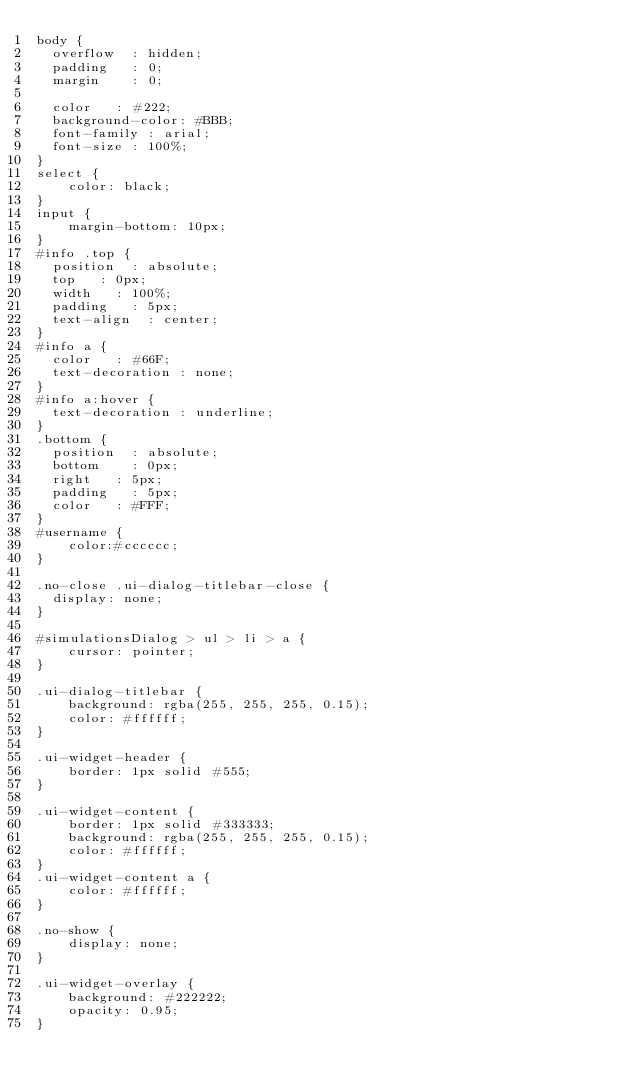Convert code to text. <code><loc_0><loc_0><loc_500><loc_500><_CSS_>body {
	overflow	: hidden;
	padding		: 0;
	margin		: 0;

	color		: #222;
	background-color: #BBB;
	font-family	: arial;
	font-size	: 100%;
}
select {
    color: black;
}
input {
    margin-bottom: 10px;
}
#info .top {
	position	: absolute;
	top		: 0px;
	width		: 100%;
	padding		: 5px;
	text-align	: center;
}
#info a {
	color		: #66F;
	text-decoration	: none;
}
#info a:hover {
	text-decoration	: underline;
}
.bottom {
	position	: absolute;
	bottom		: 0px;
	right		: 5px;
	padding		: 5px;
	color		: #FFF;
}
#username {
    color:#cccccc;
}

.no-close .ui-dialog-titlebar-close {
	display: none;
}

#simulationsDialog > ul > li > a {
    cursor: pointer;
}

.ui-dialog-titlebar {
    background: rgba(255, 255, 255, 0.15);
    color: #ffffff;
}

.ui-widget-header {
    border: 1px solid #555;
}
    
.ui-widget-content {
    border: 1px solid #333333;
    background: rgba(255, 255, 255, 0.15);
    color: #ffffff;
}
.ui-widget-content a {
    color: #ffffff;
}

.no-show {
    display: none;
}

.ui-widget-overlay {
    background: #222222;
    opacity: 0.95;
}

</code> 